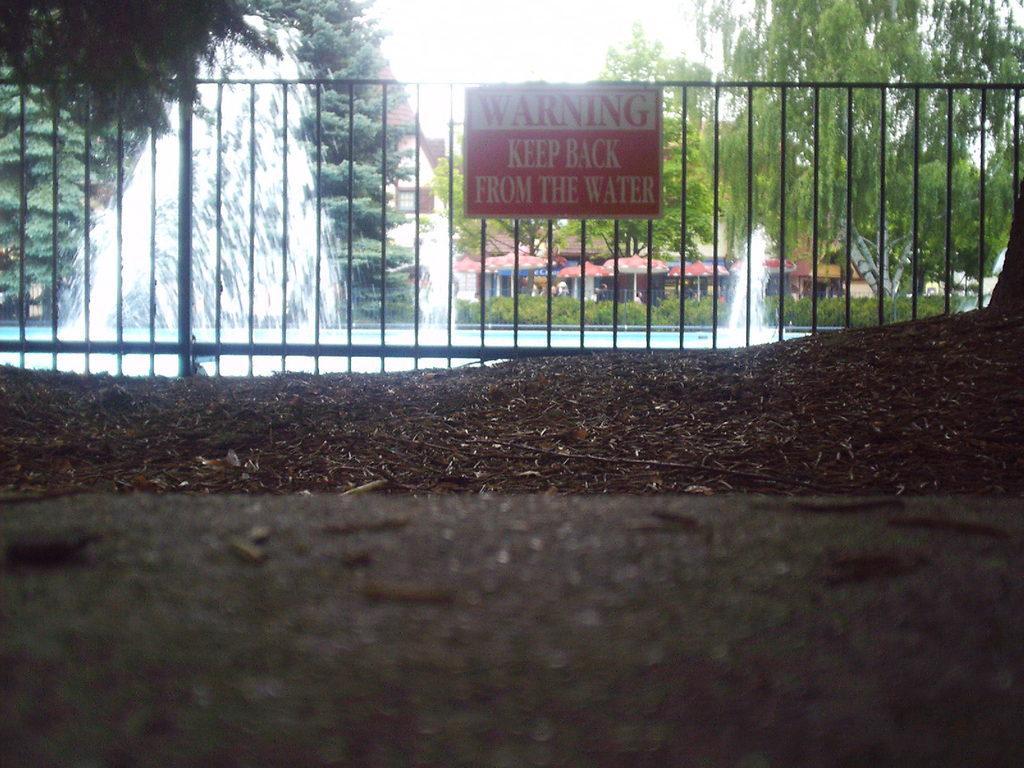Could you give a brief overview of what you see in this image? In this image in the center there is a fence and there is a board with some text written on it. Behind the fence there are trees, there are tents and there is a waterfall. 